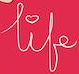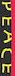Identify the words shown in these images in order, separated by a semicolon. life; PEACE 